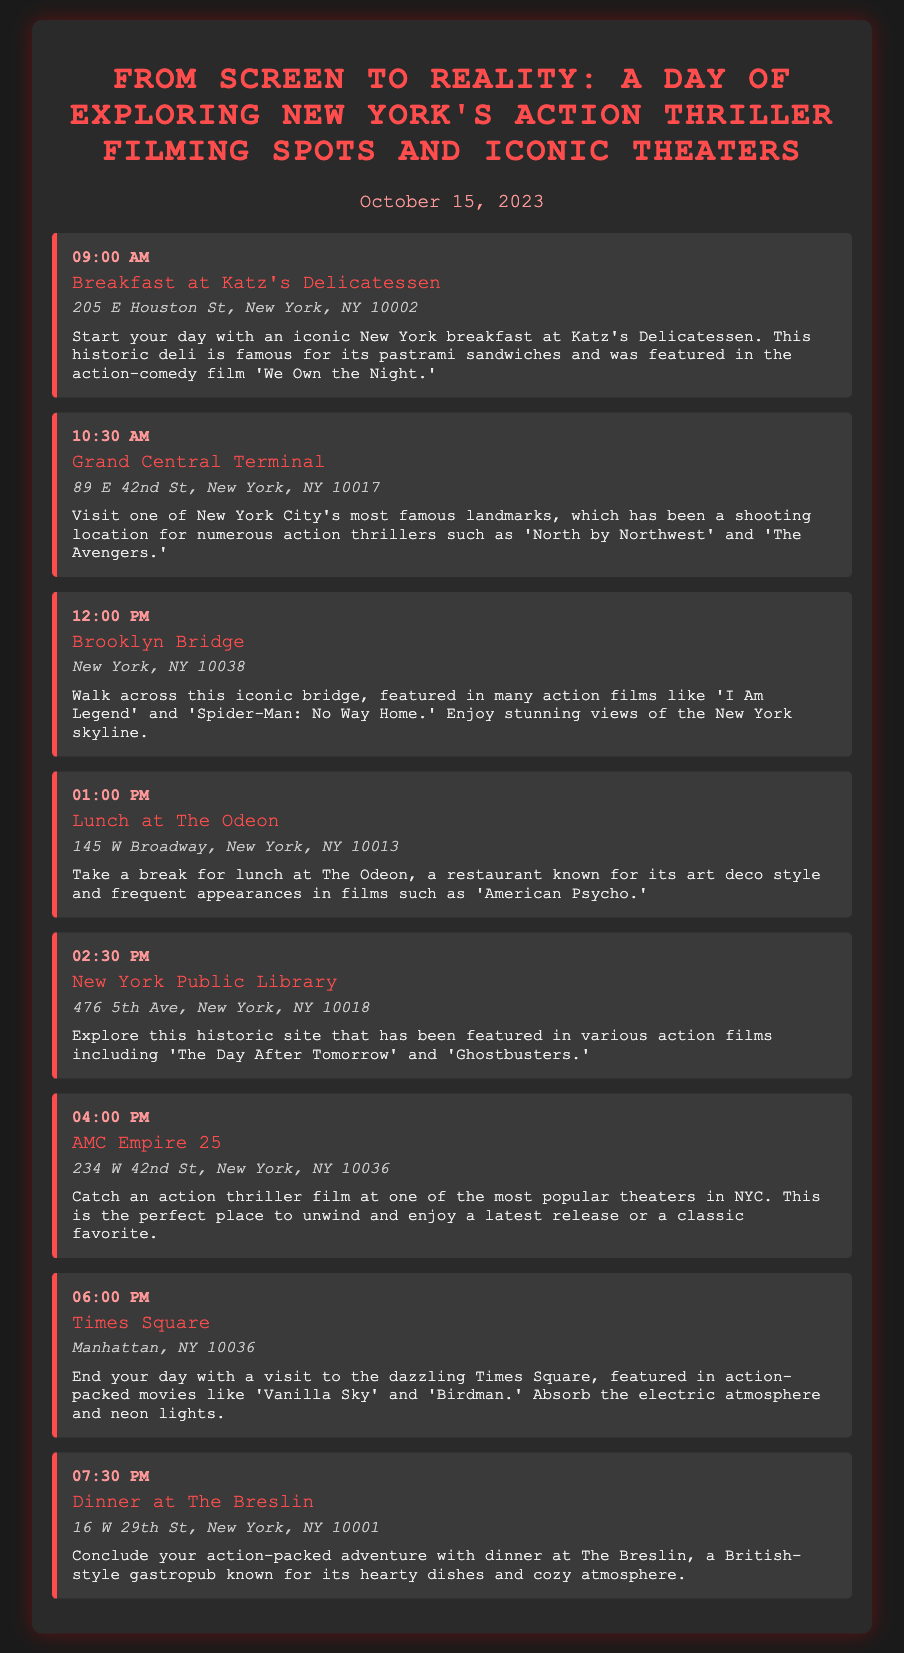What time does the tour start? The tour starts with breakfast at 09:00 AM.
Answer: 09:00 AM Which restaurant is known for its pastrami sandwiches? Katz's Delicatessen is famous for its pastrami sandwiches.
Answer: Katz's Delicatessen What iconic bridge is featured in many action films? The Brooklyn Bridge is featured in many action films.
Answer: Brooklyn Bridge Where can you catch an action thriller film? You can catch a film at AMC Empire 25.
Answer: AMC Empire 25 How long is the visit to Grand Central Terminal? The visit to Grand Central Terminal is from 10:30 AM to 12:00 PM, lasting 1.5 hours.
Answer: 1.5 hours Which activity is scheduled before lunch? The Brooklyn Bridge walk is scheduled before lunch.
Answer: Brooklyn Bridge What is the address of The Breslin? The Breslin's address is 16 W 29th St, New York, NY 10001.
Answer: 16 W 29th St, New York, NY 10001 What film was Katz's Delicatessen featured in? Katz's Delicatessen was featured in 'We Own the Night.'
Answer: 'We Own the Night' 